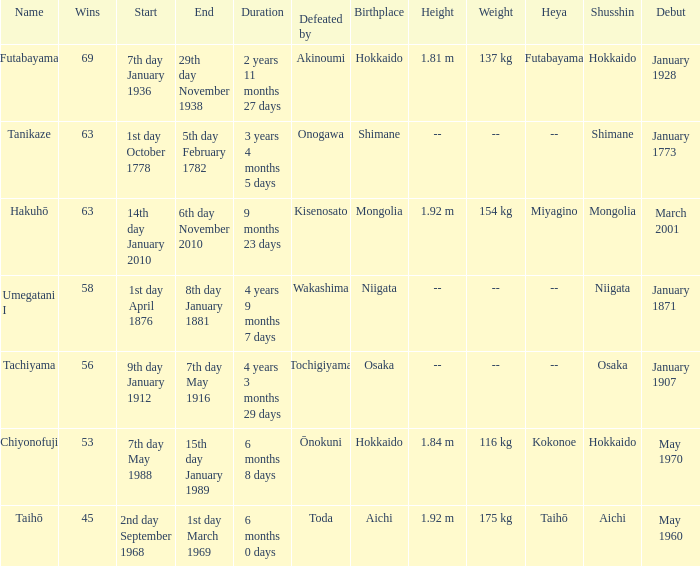How many wins were held before being defeated by toda? 1.0. 